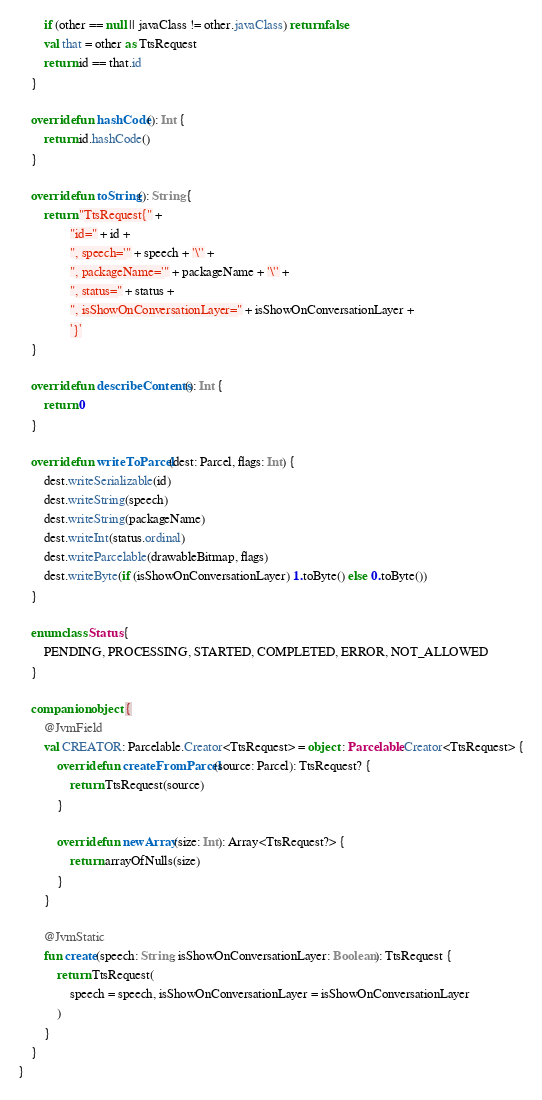<code> <loc_0><loc_0><loc_500><loc_500><_Kotlin_>        if (other == null || javaClass != other.javaClass) return false
        val that = other as TtsRequest
        return id == that.id
    }

    override fun hashCode(): Int {
        return id.hashCode()
    }

    override fun toString(): String {
        return "TtsRequest{" +
                "id=" + id +
                ", speech='" + speech + '\'' +
                ", packageName='" + packageName + '\'' +
                ", status=" + status +
                ", isShowOnConversationLayer=" + isShowOnConversationLayer +
                '}'
    }

    override fun describeContents(): Int {
        return 0
    }

    override fun writeToParcel(dest: Parcel, flags: Int) {
        dest.writeSerializable(id)
        dest.writeString(speech)
        dest.writeString(packageName)
        dest.writeInt(status.ordinal)
        dest.writeParcelable(drawableBitmap, flags)
        dest.writeByte(if (isShowOnConversationLayer) 1.toByte() else 0.toByte())
    }

    enum class Status {
        PENDING, PROCESSING, STARTED, COMPLETED, ERROR, NOT_ALLOWED
    }

    companion object {
        @JvmField
        val CREATOR: Parcelable.Creator<TtsRequest> = object : Parcelable.Creator<TtsRequest> {
            override fun createFromParcel(source: Parcel): TtsRequest? {
                return TtsRequest(source)
            }

            override fun newArray(size: Int): Array<TtsRequest?> {
                return arrayOfNulls(size)
            }
        }

        @JvmStatic
        fun create(speech: String, isShowOnConversationLayer: Boolean): TtsRequest {
            return TtsRequest(
                speech = speech, isShowOnConversationLayer = isShowOnConversationLayer
            )
        }
    }
}</code> 